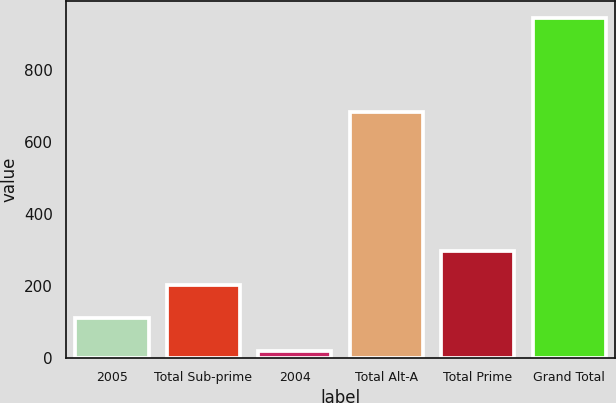Convert chart to OTSL. <chart><loc_0><loc_0><loc_500><loc_500><bar_chart><fcel>2005<fcel>Total Sub-prime<fcel>2004<fcel>Total Alt-A<fcel>Total Prime<fcel>Grand Total<nl><fcel>109.7<fcel>202.4<fcel>17<fcel>683<fcel>295.1<fcel>944<nl></chart> 